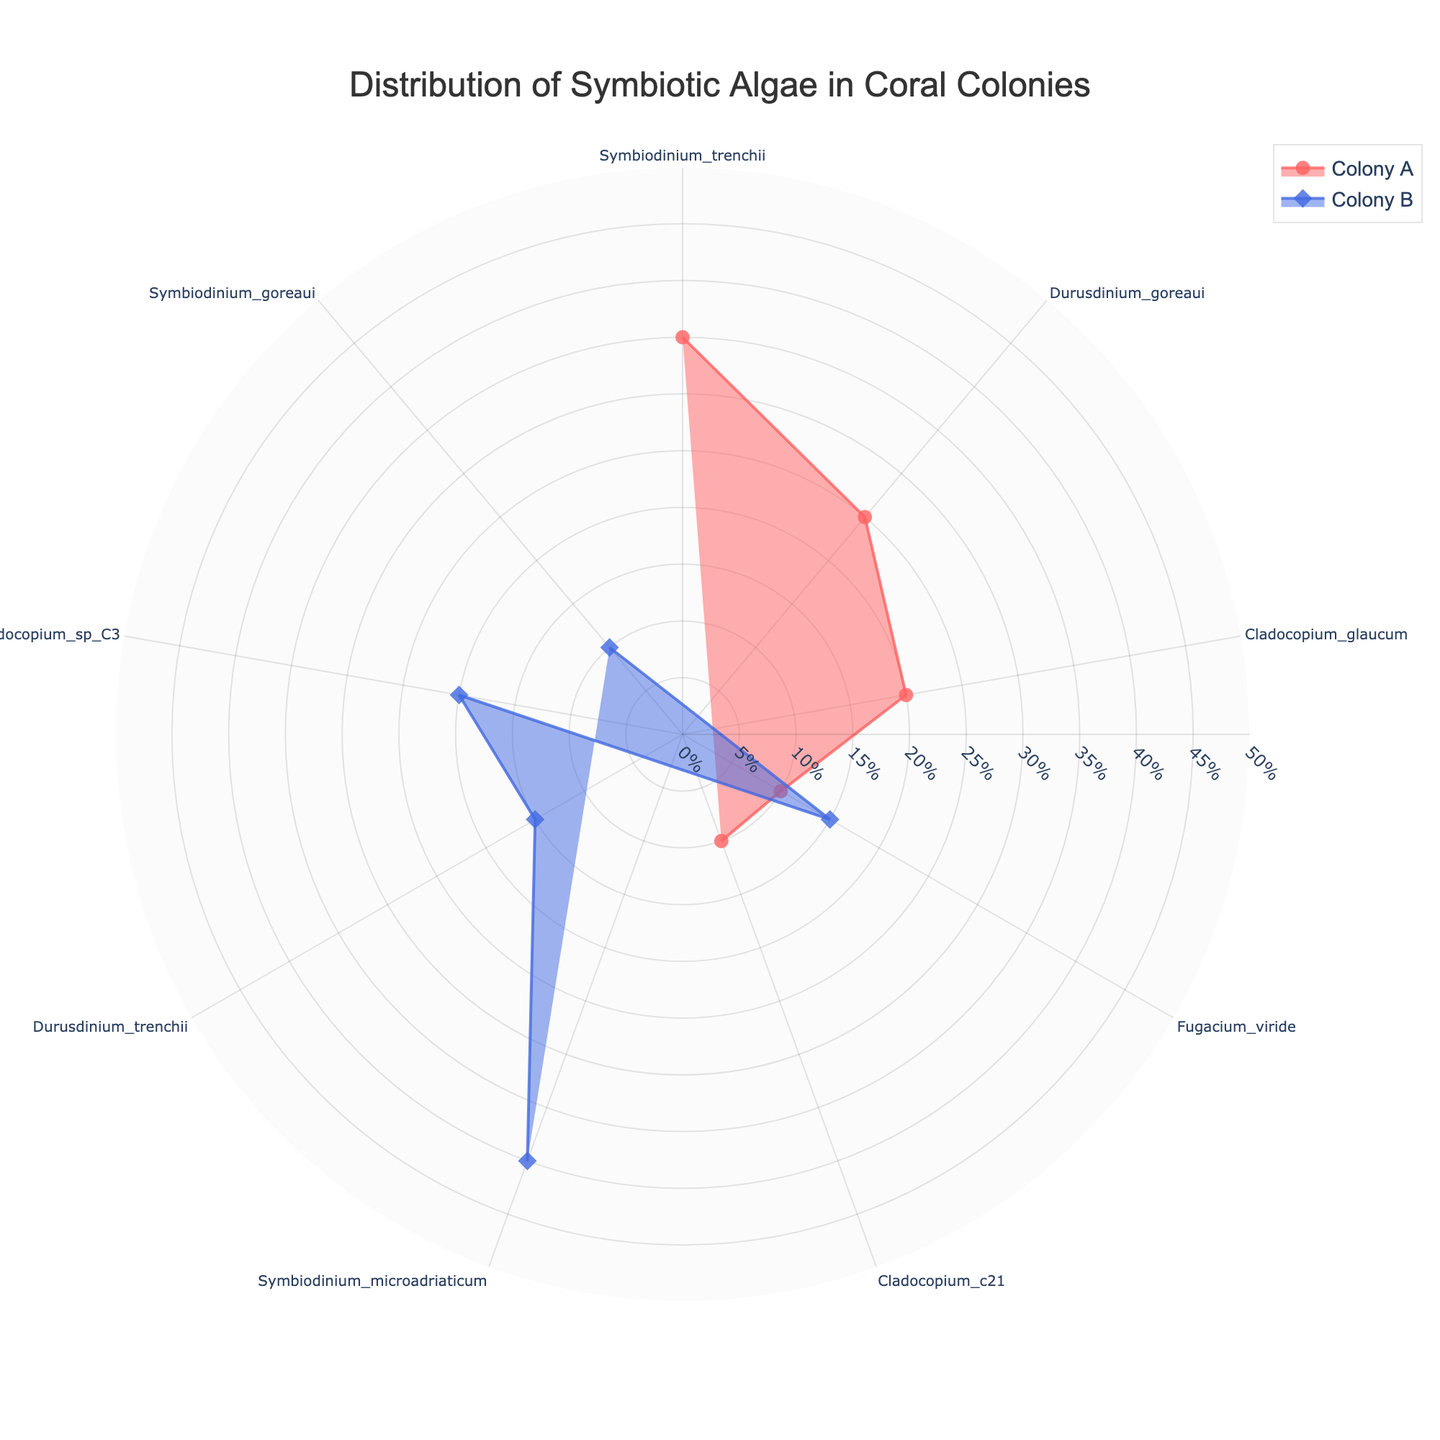What is the title of the plot? The title is usually presented prominently at the top of the figure. It provides an idea about the content of the chart. In this case, the title is centered at the top.
Answer: Distribution of Symbiotic Algae in Coral Colonies How many types of symbiotic algae are there in Colony A? To determine this, we count the different names (unique entries) of symbiotic algae under Colony A. Colony A has 5 unique symbiotic algae types.
Answer: 5 Which symbiotic algae type has the highest distribution in Colony B? By looking at the percentage values radiating from the center for Colony B, we find the highest percentage corresponds to Symbiodinium microadriaticum, which has 40%.
Answer: Symbiodinium microadriaticum What is the range of distribution percentages for symbiotic algae in the colonies? The distribution percentages for the symbiotic algae types are given. The minimum value is 10% and the maximum value is 40%. Thus, the range is calculated as 40% - 10%.
Answer: 30% Sum the distribution percentages of all symbiotic algae types for Colony A. Add all distribution percentages for Colony A: (35% + 25% + 20% + 10% + 10%) = 100%.
Answer: 100% Which type of symbiotic algae is present in both Colony A and Colony B? By comparing the names of the symbiotic algae in each colony, we identify Fugacium viride as the type that is common to both Colony A and Colony B.
Answer: Fugacium viride Which colony shows a greater diversity in symbiotic algae types? Diversity in this context can be measured by the number of different types of symbiotic algae. Colony A has 5 types, and Colony B has 5 types as well. Therefore, both show equal diversity.
Answer: Both the same For Colony A, what is the difference between the highest and lowest distribution of symbiotic algae percentages? Subtract the lowest percentage (10% for Cladocopium c21 and Fugacium viride) from the highest percentage (35% for Symbiodinium trenchii) for Colony A. 35% - 10% = 25%.
Answer: 25% What is the average distribution percentage of symbiotic algae in Colony B? To find the average, sum the distribution percentages for Colony B (40% + 15% + 20% + 15% + 10%) = 100%, and divide by the number of types, which is 5. The average is 100% / 5.
Answer: 20% Which colony has a higher overall percentage of Durusdinium algae species, considering all types within each colony? For Colony A, the type is Durusdinium goreaui with 25%. For Colony B, it is Durusdinium trenchii with 15%. Compare these two values.
Answer: Colony A 